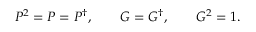<formula> <loc_0><loc_0><loc_500><loc_500>P ^ { 2 } = P = P ^ { \dagger } , \quad G = G ^ { \dagger } , \quad G ^ { 2 } = 1 .</formula> 